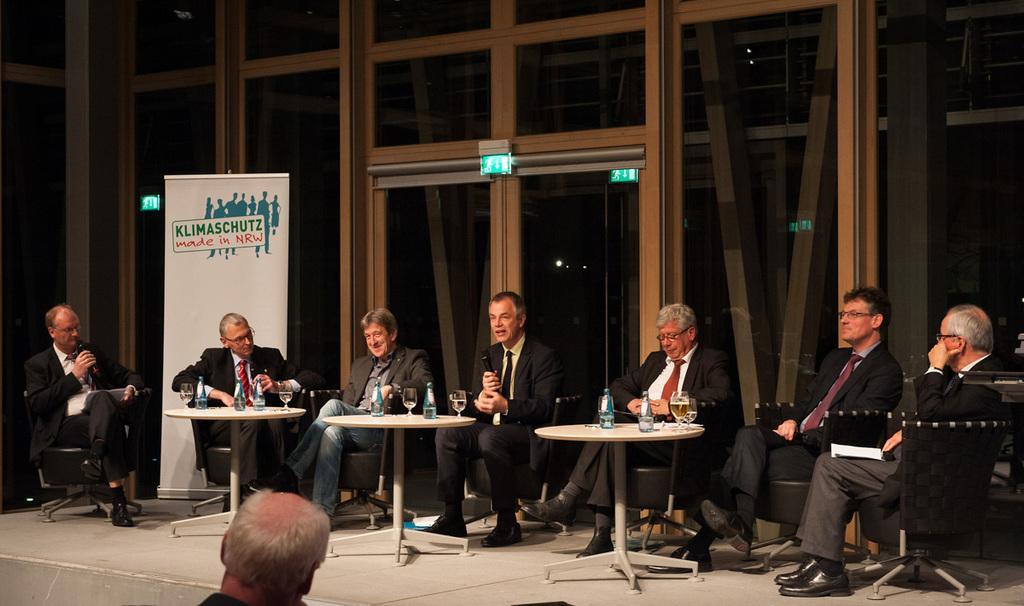Could you give a brief overview of what you see in this image? In the image we can see few persons were sitting on the chair around the table. The left and the center persons were holding microphone. On table there is a water bottle and glasses. In bottom we can see one man standing. In the background there is a glass,sign board and light. 